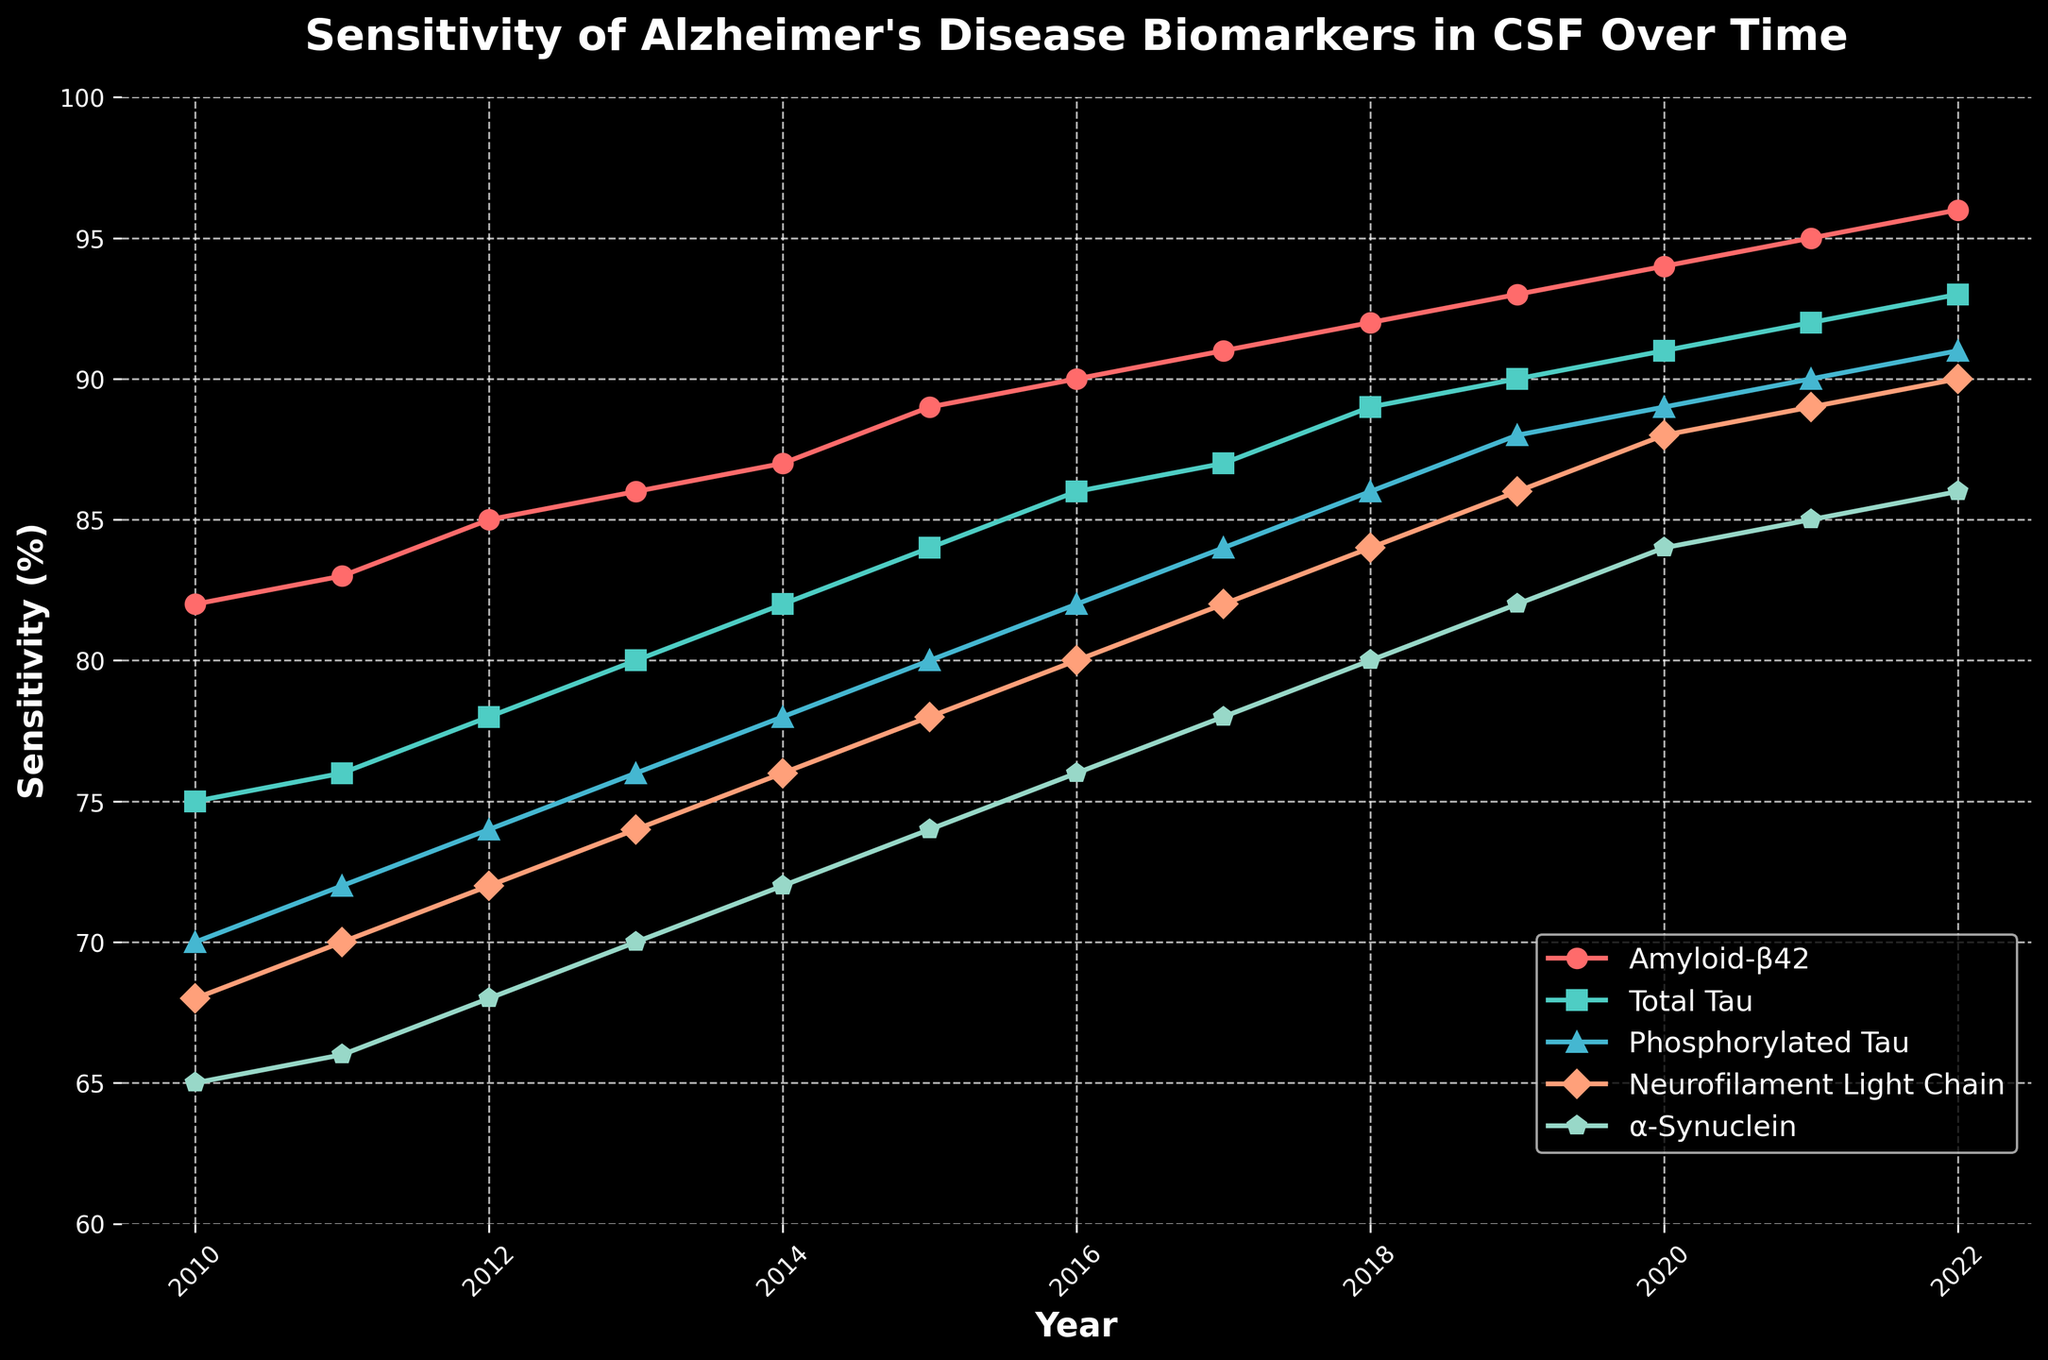What's the trend in the sensitivity of Amyloid-β42 from 2010 to 2022? The sensitivity of Amyloid-β42 increases consistently each year. Starting from 82% in 2010 and rising to 96% in 2022, it shows a clear upward trend throughout the period.
Answer: Increasing trend Which biomarker had the lowest sensitivity in 2010 and how much was it? By observing the sensitivity values in 2010, α-Synuclein had the lowest sensitivity among the biomarkers, with a sensitivity of 65%.
Answer: α-Synuclein, 65% Between 2014 and 2020, how much did the sensitivity of Total Tau increase? The sensitivity of Total Tau in 2014 was 82%. By 2020, it was 91%. The increase can be calculated by subtracting the 2014 value from the 2020 value: 91 - 82 = 9%.
Answer: 9% How does the sensitivity of Neurofilament Light Chain in 2016 compare to its sensitivity in 2012? In 2016, the sensitivity of Neurofilament Light Chain was 80%, and in 2012, it was 72%. Comparing these values shows an increase: 80% is greater than 72%.
Answer: Greater in 2016 Which biomarker shows the most significant improvement in sensitivity from 2010 to 2022? To find out which biomarker shows the most significant improvement, calculate the difference in sensitivity values from 2010 to 2022 for each biomarker. Amyloid-β42: 96-82=14, Total Tau: 93-75=18, Phosphorylated Tau: 91-70=21, Neurofilament Light Chain: 90-68=22, α-Synuclein: 86-65=21. Neurofilament Light Chain shows the most significant improvement with an increase of 22%.
Answer: Neurofilament Light Chain Are there any years where the sensitivity of Phosphorylated Tau was equal to α-Synuclein? By examining the sensitivity values of Phosphorylated Tau and α-Synuclein over the years, we see no years where their sensitivities are equal. The closest values are in 2011 (72% vs. 66%) and 2022 (91% vs. 86%), but they are never equal.
Answer: No What is the average sensitivity of Amyloid-β42 over the entire period from 2010 to 2022? Sum the sensitivity values of Amyloid-β42 from 2010 to 2022: 82 + 83 + 85 + 86 + 87 + 89 + 90 + 91 + 92 + 93 + 94 + 95 + 96 = 1253. Then, divide by the number of years (13): 1253/13 = 96.38%.
Answer: 96.38% How does the sensitivity of Phosphorylated Tau in 2019 compare to that of Total Tau in 2016? The sensitivity of Phosphorylated Tau in 2019 was 88%, while the sensitivity of Total Tau in 2016 was 86%. Comparing these values shows that Phosphorylated Tau in 2019 is greater: 88% vs. 86%.
Answer: Greater in 2019 What is the difference in sensitivity between the highest and lowest biomarker in 2022? For 2022, the sensitivity values are Amyloid-β42: 96%, Total Tau: 93%, Phosphorylated Tau: 91%, Neurofilament Light Chain: 90%, and α-Synuclein: 86%. The highest value is 96% (Amyloid-β42), and the lowest is 86% (α-Synuclein). The difference is: 96 - 86 = 10%.
Answer: 10% In which year did Neurofilament Light Chain reach an 80% sensitivity? By following the trend of Neurofilament Light Chain in the plot, it reached 80% sensitivity in the year 2016.
Answer: 2016 